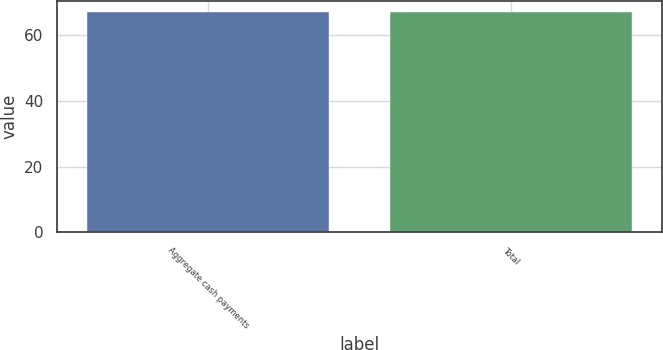Convert chart. <chart><loc_0><loc_0><loc_500><loc_500><bar_chart><fcel>Aggregate cash payments<fcel>Total<nl><fcel>67<fcel>67.1<nl></chart> 